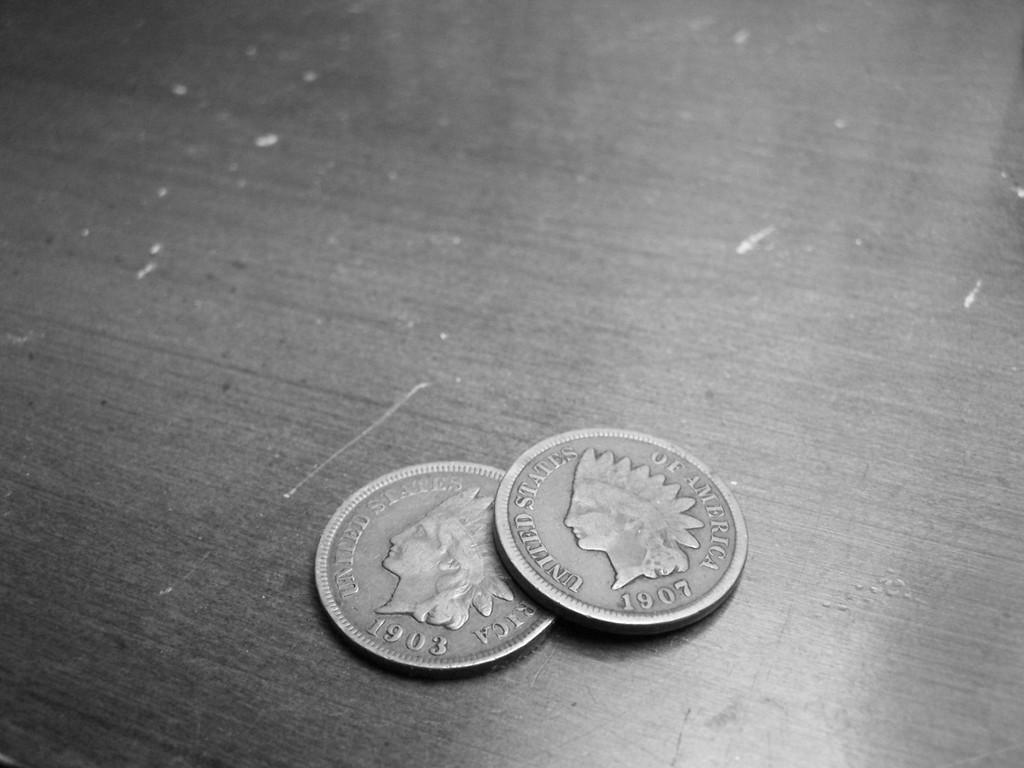<image>
Render a clear and concise summary of the photo. A pair of silver coins that say United States on them. 